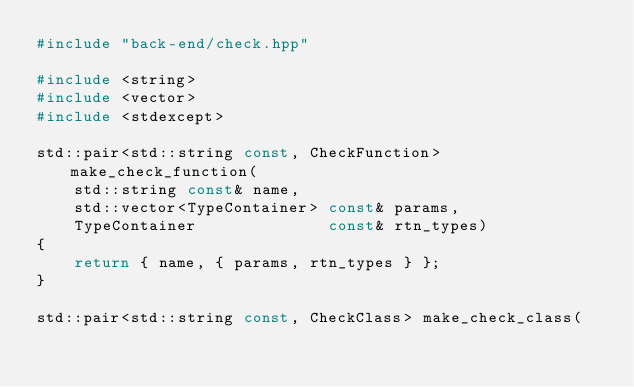Convert code to text. <code><loc_0><loc_0><loc_500><loc_500><_C++_>#include "back-end/check.hpp"

#include <string>
#include <vector>
#include <stdexcept>

std::pair<std::string const, CheckFunction> make_check_function(
	std::string const& name,
	std::vector<TypeContainer> const& params,
	TypeContainer			   const& rtn_types)
{
	return { name, { params, rtn_types } };
}

std::pair<std::string const, CheckClass> make_check_class(</code> 